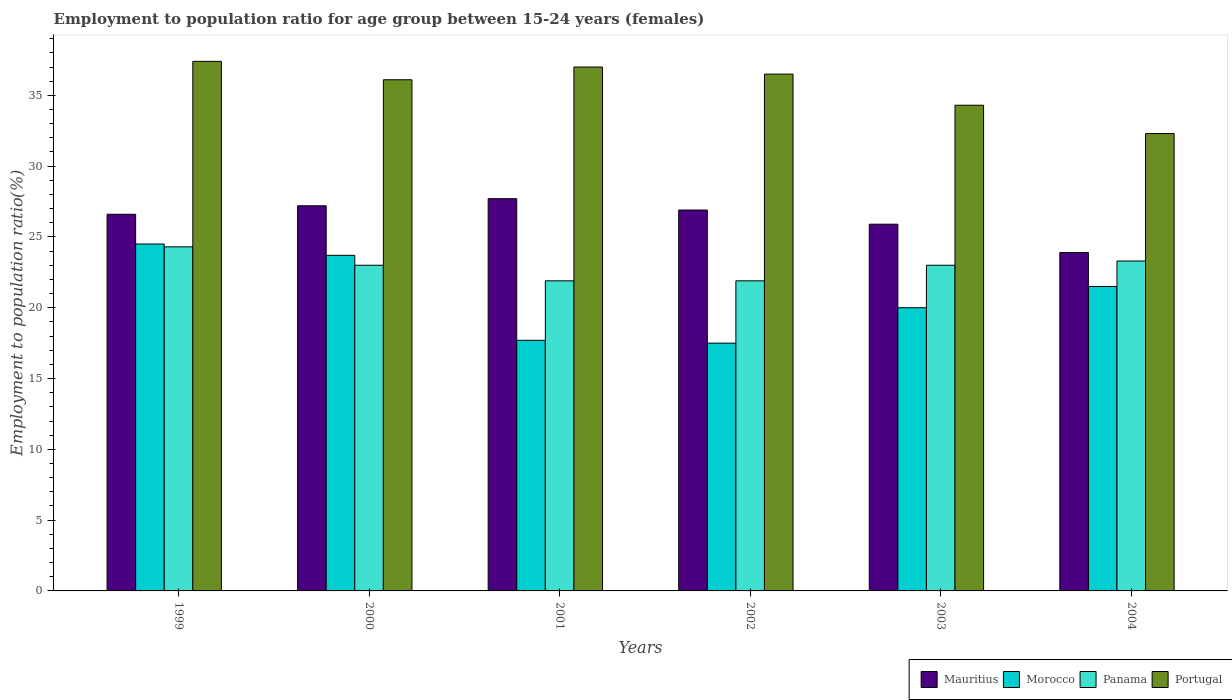How many different coloured bars are there?
Provide a short and direct response. 4. Are the number of bars on each tick of the X-axis equal?
Offer a very short reply. Yes. How many bars are there on the 4th tick from the left?
Your answer should be very brief. 4. What is the employment to population ratio in Portugal in 2002?
Offer a terse response. 36.5. Across all years, what is the maximum employment to population ratio in Portugal?
Give a very brief answer. 37.4. Across all years, what is the minimum employment to population ratio in Panama?
Offer a terse response. 21.9. In which year was the employment to population ratio in Panama maximum?
Offer a very short reply. 1999. What is the total employment to population ratio in Portugal in the graph?
Provide a short and direct response. 213.6. What is the difference between the employment to population ratio in Morocco in 1999 and that in 2002?
Make the answer very short. 7. What is the difference between the employment to population ratio in Morocco in 2003 and the employment to population ratio in Mauritius in 2004?
Ensure brevity in your answer.  -3.9. What is the average employment to population ratio in Morocco per year?
Offer a very short reply. 20.82. In the year 2003, what is the difference between the employment to population ratio in Portugal and employment to population ratio in Morocco?
Offer a terse response. 14.3. What is the ratio of the employment to population ratio in Mauritius in 2003 to that in 2004?
Your answer should be compact. 1.08. Is the employment to population ratio in Morocco in 1999 less than that in 2001?
Offer a very short reply. No. What is the difference between the highest and the second highest employment to population ratio in Morocco?
Provide a succinct answer. 0.8. What is the difference between the highest and the lowest employment to population ratio in Mauritius?
Keep it short and to the point. 3.8. In how many years, is the employment to population ratio in Portugal greater than the average employment to population ratio in Portugal taken over all years?
Provide a succinct answer. 4. What does the 1st bar from the left in 2000 represents?
Provide a succinct answer. Mauritius. Is it the case that in every year, the sum of the employment to population ratio in Mauritius and employment to population ratio in Portugal is greater than the employment to population ratio in Morocco?
Offer a very short reply. Yes. How many years are there in the graph?
Keep it short and to the point. 6. What is the difference between two consecutive major ticks on the Y-axis?
Your answer should be compact. 5. Does the graph contain any zero values?
Offer a very short reply. No. Does the graph contain grids?
Provide a short and direct response. No. Where does the legend appear in the graph?
Offer a terse response. Bottom right. How many legend labels are there?
Ensure brevity in your answer.  4. How are the legend labels stacked?
Provide a short and direct response. Horizontal. What is the title of the graph?
Offer a terse response. Employment to population ratio for age group between 15-24 years (females). Does "Liechtenstein" appear as one of the legend labels in the graph?
Your answer should be compact. No. What is the label or title of the X-axis?
Offer a very short reply. Years. What is the label or title of the Y-axis?
Ensure brevity in your answer.  Employment to population ratio(%). What is the Employment to population ratio(%) of Mauritius in 1999?
Provide a succinct answer. 26.6. What is the Employment to population ratio(%) in Morocco in 1999?
Provide a succinct answer. 24.5. What is the Employment to population ratio(%) of Panama in 1999?
Your answer should be very brief. 24.3. What is the Employment to population ratio(%) of Portugal in 1999?
Offer a very short reply. 37.4. What is the Employment to population ratio(%) of Mauritius in 2000?
Provide a succinct answer. 27.2. What is the Employment to population ratio(%) of Morocco in 2000?
Ensure brevity in your answer.  23.7. What is the Employment to population ratio(%) in Panama in 2000?
Ensure brevity in your answer.  23. What is the Employment to population ratio(%) of Portugal in 2000?
Your answer should be compact. 36.1. What is the Employment to population ratio(%) in Mauritius in 2001?
Offer a very short reply. 27.7. What is the Employment to population ratio(%) in Morocco in 2001?
Your answer should be compact. 17.7. What is the Employment to population ratio(%) of Panama in 2001?
Provide a succinct answer. 21.9. What is the Employment to population ratio(%) of Portugal in 2001?
Your answer should be compact. 37. What is the Employment to population ratio(%) of Mauritius in 2002?
Provide a short and direct response. 26.9. What is the Employment to population ratio(%) of Morocco in 2002?
Give a very brief answer. 17.5. What is the Employment to population ratio(%) in Panama in 2002?
Your response must be concise. 21.9. What is the Employment to population ratio(%) in Portugal in 2002?
Ensure brevity in your answer.  36.5. What is the Employment to population ratio(%) in Mauritius in 2003?
Provide a short and direct response. 25.9. What is the Employment to population ratio(%) in Morocco in 2003?
Offer a very short reply. 20. What is the Employment to population ratio(%) in Panama in 2003?
Give a very brief answer. 23. What is the Employment to population ratio(%) in Portugal in 2003?
Make the answer very short. 34.3. What is the Employment to population ratio(%) of Mauritius in 2004?
Provide a short and direct response. 23.9. What is the Employment to population ratio(%) in Panama in 2004?
Offer a very short reply. 23.3. What is the Employment to population ratio(%) in Portugal in 2004?
Ensure brevity in your answer.  32.3. Across all years, what is the maximum Employment to population ratio(%) of Mauritius?
Ensure brevity in your answer.  27.7. Across all years, what is the maximum Employment to population ratio(%) of Morocco?
Ensure brevity in your answer.  24.5. Across all years, what is the maximum Employment to population ratio(%) in Panama?
Your response must be concise. 24.3. Across all years, what is the maximum Employment to population ratio(%) in Portugal?
Provide a succinct answer. 37.4. Across all years, what is the minimum Employment to population ratio(%) of Mauritius?
Offer a terse response. 23.9. Across all years, what is the minimum Employment to population ratio(%) in Panama?
Give a very brief answer. 21.9. Across all years, what is the minimum Employment to population ratio(%) in Portugal?
Offer a very short reply. 32.3. What is the total Employment to population ratio(%) in Mauritius in the graph?
Provide a succinct answer. 158.2. What is the total Employment to population ratio(%) of Morocco in the graph?
Offer a terse response. 124.9. What is the total Employment to population ratio(%) in Panama in the graph?
Give a very brief answer. 137.4. What is the total Employment to population ratio(%) in Portugal in the graph?
Your response must be concise. 213.6. What is the difference between the Employment to population ratio(%) in Mauritius in 1999 and that in 2000?
Your answer should be very brief. -0.6. What is the difference between the Employment to population ratio(%) in Morocco in 1999 and that in 2000?
Provide a succinct answer. 0.8. What is the difference between the Employment to population ratio(%) of Mauritius in 1999 and that in 2001?
Keep it short and to the point. -1.1. What is the difference between the Employment to population ratio(%) in Morocco in 1999 and that in 2001?
Offer a terse response. 6.8. What is the difference between the Employment to population ratio(%) of Panama in 1999 and that in 2001?
Give a very brief answer. 2.4. What is the difference between the Employment to population ratio(%) of Portugal in 1999 and that in 2001?
Provide a succinct answer. 0.4. What is the difference between the Employment to population ratio(%) in Mauritius in 1999 and that in 2002?
Your answer should be compact. -0.3. What is the difference between the Employment to population ratio(%) of Morocco in 1999 and that in 2002?
Give a very brief answer. 7. What is the difference between the Employment to population ratio(%) in Portugal in 1999 and that in 2002?
Offer a terse response. 0.9. What is the difference between the Employment to population ratio(%) of Mauritius in 1999 and that in 2003?
Your response must be concise. 0.7. What is the difference between the Employment to population ratio(%) in Morocco in 1999 and that in 2003?
Offer a terse response. 4.5. What is the difference between the Employment to population ratio(%) of Panama in 1999 and that in 2003?
Provide a short and direct response. 1.3. What is the difference between the Employment to population ratio(%) in Portugal in 1999 and that in 2003?
Give a very brief answer. 3.1. What is the difference between the Employment to population ratio(%) of Mauritius in 1999 and that in 2004?
Provide a short and direct response. 2.7. What is the difference between the Employment to population ratio(%) in Panama in 1999 and that in 2004?
Give a very brief answer. 1. What is the difference between the Employment to population ratio(%) of Portugal in 1999 and that in 2004?
Your response must be concise. 5.1. What is the difference between the Employment to population ratio(%) of Panama in 2000 and that in 2001?
Give a very brief answer. 1.1. What is the difference between the Employment to population ratio(%) in Portugal in 2000 and that in 2001?
Offer a very short reply. -0.9. What is the difference between the Employment to population ratio(%) in Morocco in 2000 and that in 2002?
Offer a very short reply. 6.2. What is the difference between the Employment to population ratio(%) of Panama in 2000 and that in 2003?
Provide a short and direct response. 0. What is the difference between the Employment to population ratio(%) of Portugal in 2000 and that in 2003?
Keep it short and to the point. 1.8. What is the difference between the Employment to population ratio(%) in Panama in 2000 and that in 2004?
Provide a succinct answer. -0.3. What is the difference between the Employment to population ratio(%) in Portugal in 2001 and that in 2002?
Offer a terse response. 0.5. What is the difference between the Employment to population ratio(%) of Morocco in 2001 and that in 2003?
Your answer should be compact. -2.3. What is the difference between the Employment to population ratio(%) of Panama in 2001 and that in 2003?
Give a very brief answer. -1.1. What is the difference between the Employment to population ratio(%) of Portugal in 2001 and that in 2003?
Your response must be concise. 2.7. What is the difference between the Employment to population ratio(%) in Mauritius in 2001 and that in 2004?
Provide a short and direct response. 3.8. What is the difference between the Employment to population ratio(%) of Panama in 2001 and that in 2004?
Offer a very short reply. -1.4. What is the difference between the Employment to population ratio(%) in Portugal in 2001 and that in 2004?
Your response must be concise. 4.7. What is the difference between the Employment to population ratio(%) of Mauritius in 2002 and that in 2003?
Offer a terse response. 1. What is the difference between the Employment to population ratio(%) of Panama in 2002 and that in 2003?
Offer a very short reply. -1.1. What is the difference between the Employment to population ratio(%) of Portugal in 2002 and that in 2003?
Give a very brief answer. 2.2. What is the difference between the Employment to population ratio(%) of Morocco in 2002 and that in 2004?
Provide a succinct answer. -4. What is the difference between the Employment to population ratio(%) of Morocco in 2003 and that in 2004?
Give a very brief answer. -1.5. What is the difference between the Employment to population ratio(%) in Mauritius in 1999 and the Employment to population ratio(%) in Morocco in 2000?
Your response must be concise. 2.9. What is the difference between the Employment to population ratio(%) in Mauritius in 1999 and the Employment to population ratio(%) in Panama in 2000?
Ensure brevity in your answer.  3.6. What is the difference between the Employment to population ratio(%) of Morocco in 1999 and the Employment to population ratio(%) of Panama in 2000?
Your answer should be very brief. 1.5. What is the difference between the Employment to population ratio(%) in Morocco in 1999 and the Employment to population ratio(%) in Portugal in 2000?
Offer a very short reply. -11.6. What is the difference between the Employment to population ratio(%) of Mauritius in 1999 and the Employment to population ratio(%) of Panama in 2001?
Offer a very short reply. 4.7. What is the difference between the Employment to population ratio(%) in Morocco in 1999 and the Employment to population ratio(%) in Panama in 2001?
Your response must be concise. 2.6. What is the difference between the Employment to population ratio(%) of Mauritius in 1999 and the Employment to population ratio(%) of Morocco in 2002?
Provide a short and direct response. 9.1. What is the difference between the Employment to population ratio(%) of Mauritius in 1999 and the Employment to population ratio(%) of Panama in 2002?
Give a very brief answer. 4.7. What is the difference between the Employment to population ratio(%) of Mauritius in 1999 and the Employment to population ratio(%) of Portugal in 2002?
Your response must be concise. -9.9. What is the difference between the Employment to population ratio(%) in Panama in 1999 and the Employment to population ratio(%) in Portugal in 2002?
Make the answer very short. -12.2. What is the difference between the Employment to population ratio(%) of Mauritius in 1999 and the Employment to population ratio(%) of Portugal in 2003?
Give a very brief answer. -7.7. What is the difference between the Employment to population ratio(%) in Morocco in 1999 and the Employment to population ratio(%) in Panama in 2003?
Offer a very short reply. 1.5. What is the difference between the Employment to population ratio(%) in Morocco in 1999 and the Employment to population ratio(%) in Panama in 2004?
Provide a succinct answer. 1.2. What is the difference between the Employment to population ratio(%) of Panama in 1999 and the Employment to population ratio(%) of Portugal in 2004?
Your response must be concise. -8. What is the difference between the Employment to population ratio(%) of Mauritius in 2000 and the Employment to population ratio(%) of Panama in 2001?
Offer a terse response. 5.3. What is the difference between the Employment to population ratio(%) in Morocco in 2000 and the Employment to population ratio(%) in Panama in 2001?
Make the answer very short. 1.8. What is the difference between the Employment to population ratio(%) of Morocco in 2000 and the Employment to population ratio(%) of Portugal in 2001?
Keep it short and to the point. -13.3. What is the difference between the Employment to population ratio(%) of Panama in 2000 and the Employment to population ratio(%) of Portugal in 2001?
Provide a succinct answer. -14. What is the difference between the Employment to population ratio(%) of Mauritius in 2000 and the Employment to population ratio(%) of Morocco in 2002?
Offer a very short reply. 9.7. What is the difference between the Employment to population ratio(%) in Mauritius in 2000 and the Employment to population ratio(%) in Panama in 2002?
Give a very brief answer. 5.3. What is the difference between the Employment to population ratio(%) of Morocco in 2000 and the Employment to population ratio(%) of Panama in 2002?
Keep it short and to the point. 1.8. What is the difference between the Employment to population ratio(%) in Morocco in 2000 and the Employment to population ratio(%) in Portugal in 2002?
Make the answer very short. -12.8. What is the difference between the Employment to population ratio(%) in Mauritius in 2000 and the Employment to population ratio(%) in Morocco in 2003?
Offer a terse response. 7.2. What is the difference between the Employment to population ratio(%) in Morocco in 2000 and the Employment to population ratio(%) in Panama in 2003?
Give a very brief answer. 0.7. What is the difference between the Employment to population ratio(%) of Panama in 2000 and the Employment to population ratio(%) of Portugal in 2003?
Provide a succinct answer. -11.3. What is the difference between the Employment to population ratio(%) of Mauritius in 2000 and the Employment to population ratio(%) of Panama in 2004?
Provide a succinct answer. 3.9. What is the difference between the Employment to population ratio(%) in Morocco in 2000 and the Employment to population ratio(%) in Panama in 2004?
Provide a short and direct response. 0.4. What is the difference between the Employment to population ratio(%) in Panama in 2000 and the Employment to population ratio(%) in Portugal in 2004?
Give a very brief answer. -9.3. What is the difference between the Employment to population ratio(%) of Mauritius in 2001 and the Employment to population ratio(%) of Morocco in 2002?
Provide a succinct answer. 10.2. What is the difference between the Employment to population ratio(%) in Mauritius in 2001 and the Employment to population ratio(%) in Panama in 2002?
Ensure brevity in your answer.  5.8. What is the difference between the Employment to population ratio(%) of Mauritius in 2001 and the Employment to population ratio(%) of Portugal in 2002?
Your response must be concise. -8.8. What is the difference between the Employment to population ratio(%) in Morocco in 2001 and the Employment to population ratio(%) in Portugal in 2002?
Ensure brevity in your answer.  -18.8. What is the difference between the Employment to population ratio(%) in Panama in 2001 and the Employment to population ratio(%) in Portugal in 2002?
Provide a succinct answer. -14.6. What is the difference between the Employment to population ratio(%) in Mauritius in 2001 and the Employment to population ratio(%) in Portugal in 2003?
Offer a very short reply. -6.6. What is the difference between the Employment to population ratio(%) of Morocco in 2001 and the Employment to population ratio(%) of Portugal in 2003?
Your answer should be very brief. -16.6. What is the difference between the Employment to population ratio(%) in Panama in 2001 and the Employment to population ratio(%) in Portugal in 2003?
Your answer should be compact. -12.4. What is the difference between the Employment to population ratio(%) of Mauritius in 2001 and the Employment to population ratio(%) of Morocco in 2004?
Offer a terse response. 6.2. What is the difference between the Employment to population ratio(%) of Morocco in 2001 and the Employment to population ratio(%) of Panama in 2004?
Provide a succinct answer. -5.6. What is the difference between the Employment to population ratio(%) of Morocco in 2001 and the Employment to population ratio(%) of Portugal in 2004?
Provide a succinct answer. -14.6. What is the difference between the Employment to population ratio(%) of Panama in 2001 and the Employment to population ratio(%) of Portugal in 2004?
Make the answer very short. -10.4. What is the difference between the Employment to population ratio(%) in Mauritius in 2002 and the Employment to population ratio(%) in Morocco in 2003?
Provide a succinct answer. 6.9. What is the difference between the Employment to population ratio(%) of Mauritius in 2002 and the Employment to population ratio(%) of Panama in 2003?
Ensure brevity in your answer.  3.9. What is the difference between the Employment to population ratio(%) in Mauritius in 2002 and the Employment to population ratio(%) in Portugal in 2003?
Provide a succinct answer. -7.4. What is the difference between the Employment to population ratio(%) of Morocco in 2002 and the Employment to population ratio(%) of Portugal in 2003?
Provide a short and direct response. -16.8. What is the difference between the Employment to population ratio(%) of Panama in 2002 and the Employment to population ratio(%) of Portugal in 2003?
Provide a short and direct response. -12.4. What is the difference between the Employment to population ratio(%) of Mauritius in 2002 and the Employment to population ratio(%) of Portugal in 2004?
Keep it short and to the point. -5.4. What is the difference between the Employment to population ratio(%) of Morocco in 2002 and the Employment to population ratio(%) of Portugal in 2004?
Give a very brief answer. -14.8. What is the difference between the Employment to population ratio(%) of Panama in 2002 and the Employment to population ratio(%) of Portugal in 2004?
Your response must be concise. -10.4. What is the difference between the Employment to population ratio(%) in Mauritius in 2003 and the Employment to population ratio(%) in Morocco in 2004?
Your answer should be compact. 4.4. What is the difference between the Employment to population ratio(%) in Mauritius in 2003 and the Employment to population ratio(%) in Portugal in 2004?
Make the answer very short. -6.4. What is the difference between the Employment to population ratio(%) in Morocco in 2003 and the Employment to population ratio(%) in Panama in 2004?
Your answer should be compact. -3.3. What is the difference between the Employment to population ratio(%) in Morocco in 2003 and the Employment to population ratio(%) in Portugal in 2004?
Offer a terse response. -12.3. What is the difference between the Employment to population ratio(%) of Panama in 2003 and the Employment to population ratio(%) of Portugal in 2004?
Offer a terse response. -9.3. What is the average Employment to population ratio(%) of Mauritius per year?
Provide a short and direct response. 26.37. What is the average Employment to population ratio(%) in Morocco per year?
Provide a short and direct response. 20.82. What is the average Employment to population ratio(%) in Panama per year?
Give a very brief answer. 22.9. What is the average Employment to population ratio(%) in Portugal per year?
Ensure brevity in your answer.  35.6. In the year 1999, what is the difference between the Employment to population ratio(%) in Mauritius and Employment to population ratio(%) in Morocco?
Offer a terse response. 2.1. In the year 1999, what is the difference between the Employment to population ratio(%) in Mauritius and Employment to population ratio(%) in Panama?
Make the answer very short. 2.3. In the year 1999, what is the difference between the Employment to population ratio(%) in Mauritius and Employment to population ratio(%) in Portugal?
Your response must be concise. -10.8. In the year 1999, what is the difference between the Employment to population ratio(%) of Morocco and Employment to population ratio(%) of Panama?
Keep it short and to the point. 0.2. In the year 1999, what is the difference between the Employment to population ratio(%) in Panama and Employment to population ratio(%) in Portugal?
Your answer should be very brief. -13.1. In the year 2000, what is the difference between the Employment to population ratio(%) in Mauritius and Employment to population ratio(%) in Morocco?
Provide a short and direct response. 3.5. In the year 2000, what is the difference between the Employment to population ratio(%) of Mauritius and Employment to population ratio(%) of Portugal?
Give a very brief answer. -8.9. In the year 2000, what is the difference between the Employment to population ratio(%) of Morocco and Employment to population ratio(%) of Panama?
Make the answer very short. 0.7. In the year 2001, what is the difference between the Employment to population ratio(%) of Morocco and Employment to population ratio(%) of Panama?
Your answer should be compact. -4.2. In the year 2001, what is the difference between the Employment to population ratio(%) in Morocco and Employment to population ratio(%) in Portugal?
Offer a very short reply. -19.3. In the year 2001, what is the difference between the Employment to population ratio(%) of Panama and Employment to population ratio(%) of Portugal?
Make the answer very short. -15.1. In the year 2002, what is the difference between the Employment to population ratio(%) in Mauritius and Employment to population ratio(%) in Panama?
Make the answer very short. 5. In the year 2002, what is the difference between the Employment to population ratio(%) in Morocco and Employment to population ratio(%) in Panama?
Your answer should be compact. -4.4. In the year 2002, what is the difference between the Employment to population ratio(%) of Morocco and Employment to population ratio(%) of Portugal?
Provide a succinct answer. -19. In the year 2002, what is the difference between the Employment to population ratio(%) of Panama and Employment to population ratio(%) of Portugal?
Ensure brevity in your answer.  -14.6. In the year 2003, what is the difference between the Employment to population ratio(%) in Mauritius and Employment to population ratio(%) in Panama?
Provide a succinct answer. 2.9. In the year 2003, what is the difference between the Employment to population ratio(%) in Morocco and Employment to population ratio(%) in Panama?
Ensure brevity in your answer.  -3. In the year 2003, what is the difference between the Employment to population ratio(%) of Morocco and Employment to population ratio(%) of Portugal?
Offer a terse response. -14.3. In the year 2003, what is the difference between the Employment to population ratio(%) in Panama and Employment to population ratio(%) in Portugal?
Give a very brief answer. -11.3. In the year 2004, what is the difference between the Employment to population ratio(%) in Panama and Employment to population ratio(%) in Portugal?
Provide a short and direct response. -9. What is the ratio of the Employment to population ratio(%) of Mauritius in 1999 to that in 2000?
Provide a succinct answer. 0.98. What is the ratio of the Employment to population ratio(%) of Morocco in 1999 to that in 2000?
Make the answer very short. 1.03. What is the ratio of the Employment to population ratio(%) of Panama in 1999 to that in 2000?
Make the answer very short. 1.06. What is the ratio of the Employment to population ratio(%) in Portugal in 1999 to that in 2000?
Ensure brevity in your answer.  1.04. What is the ratio of the Employment to population ratio(%) of Mauritius in 1999 to that in 2001?
Provide a succinct answer. 0.96. What is the ratio of the Employment to population ratio(%) of Morocco in 1999 to that in 2001?
Offer a very short reply. 1.38. What is the ratio of the Employment to population ratio(%) in Panama in 1999 to that in 2001?
Offer a very short reply. 1.11. What is the ratio of the Employment to population ratio(%) in Portugal in 1999 to that in 2001?
Your answer should be compact. 1.01. What is the ratio of the Employment to population ratio(%) of Mauritius in 1999 to that in 2002?
Offer a very short reply. 0.99. What is the ratio of the Employment to population ratio(%) in Morocco in 1999 to that in 2002?
Keep it short and to the point. 1.4. What is the ratio of the Employment to population ratio(%) in Panama in 1999 to that in 2002?
Your answer should be compact. 1.11. What is the ratio of the Employment to population ratio(%) of Portugal in 1999 to that in 2002?
Ensure brevity in your answer.  1.02. What is the ratio of the Employment to population ratio(%) in Morocco in 1999 to that in 2003?
Ensure brevity in your answer.  1.23. What is the ratio of the Employment to population ratio(%) in Panama in 1999 to that in 2003?
Make the answer very short. 1.06. What is the ratio of the Employment to population ratio(%) in Portugal in 1999 to that in 2003?
Offer a terse response. 1.09. What is the ratio of the Employment to population ratio(%) of Mauritius in 1999 to that in 2004?
Your answer should be compact. 1.11. What is the ratio of the Employment to population ratio(%) in Morocco in 1999 to that in 2004?
Provide a succinct answer. 1.14. What is the ratio of the Employment to population ratio(%) of Panama in 1999 to that in 2004?
Offer a very short reply. 1.04. What is the ratio of the Employment to population ratio(%) in Portugal in 1999 to that in 2004?
Your answer should be compact. 1.16. What is the ratio of the Employment to population ratio(%) in Mauritius in 2000 to that in 2001?
Provide a succinct answer. 0.98. What is the ratio of the Employment to population ratio(%) of Morocco in 2000 to that in 2001?
Your answer should be very brief. 1.34. What is the ratio of the Employment to population ratio(%) of Panama in 2000 to that in 2001?
Offer a very short reply. 1.05. What is the ratio of the Employment to population ratio(%) in Portugal in 2000 to that in 2001?
Keep it short and to the point. 0.98. What is the ratio of the Employment to population ratio(%) of Mauritius in 2000 to that in 2002?
Provide a succinct answer. 1.01. What is the ratio of the Employment to population ratio(%) of Morocco in 2000 to that in 2002?
Offer a very short reply. 1.35. What is the ratio of the Employment to population ratio(%) of Panama in 2000 to that in 2002?
Keep it short and to the point. 1.05. What is the ratio of the Employment to population ratio(%) in Portugal in 2000 to that in 2002?
Offer a very short reply. 0.99. What is the ratio of the Employment to population ratio(%) in Mauritius in 2000 to that in 2003?
Your answer should be very brief. 1.05. What is the ratio of the Employment to population ratio(%) of Morocco in 2000 to that in 2003?
Give a very brief answer. 1.19. What is the ratio of the Employment to population ratio(%) in Panama in 2000 to that in 2003?
Make the answer very short. 1. What is the ratio of the Employment to population ratio(%) of Portugal in 2000 to that in 2003?
Your response must be concise. 1.05. What is the ratio of the Employment to population ratio(%) in Mauritius in 2000 to that in 2004?
Your answer should be compact. 1.14. What is the ratio of the Employment to population ratio(%) of Morocco in 2000 to that in 2004?
Your response must be concise. 1.1. What is the ratio of the Employment to population ratio(%) in Panama in 2000 to that in 2004?
Offer a very short reply. 0.99. What is the ratio of the Employment to population ratio(%) of Portugal in 2000 to that in 2004?
Your answer should be compact. 1.12. What is the ratio of the Employment to population ratio(%) of Mauritius in 2001 to that in 2002?
Provide a short and direct response. 1.03. What is the ratio of the Employment to population ratio(%) in Morocco in 2001 to that in 2002?
Your response must be concise. 1.01. What is the ratio of the Employment to population ratio(%) of Panama in 2001 to that in 2002?
Provide a short and direct response. 1. What is the ratio of the Employment to population ratio(%) of Portugal in 2001 to that in 2002?
Make the answer very short. 1.01. What is the ratio of the Employment to population ratio(%) of Mauritius in 2001 to that in 2003?
Give a very brief answer. 1.07. What is the ratio of the Employment to population ratio(%) in Morocco in 2001 to that in 2003?
Offer a very short reply. 0.89. What is the ratio of the Employment to population ratio(%) of Panama in 2001 to that in 2003?
Offer a very short reply. 0.95. What is the ratio of the Employment to population ratio(%) of Portugal in 2001 to that in 2003?
Offer a terse response. 1.08. What is the ratio of the Employment to population ratio(%) in Mauritius in 2001 to that in 2004?
Offer a very short reply. 1.16. What is the ratio of the Employment to population ratio(%) of Morocco in 2001 to that in 2004?
Provide a succinct answer. 0.82. What is the ratio of the Employment to population ratio(%) in Panama in 2001 to that in 2004?
Your response must be concise. 0.94. What is the ratio of the Employment to population ratio(%) in Portugal in 2001 to that in 2004?
Offer a very short reply. 1.15. What is the ratio of the Employment to population ratio(%) in Mauritius in 2002 to that in 2003?
Ensure brevity in your answer.  1.04. What is the ratio of the Employment to population ratio(%) in Panama in 2002 to that in 2003?
Your response must be concise. 0.95. What is the ratio of the Employment to population ratio(%) of Portugal in 2002 to that in 2003?
Your answer should be very brief. 1.06. What is the ratio of the Employment to population ratio(%) of Mauritius in 2002 to that in 2004?
Offer a very short reply. 1.13. What is the ratio of the Employment to population ratio(%) of Morocco in 2002 to that in 2004?
Your answer should be compact. 0.81. What is the ratio of the Employment to population ratio(%) of Panama in 2002 to that in 2004?
Provide a short and direct response. 0.94. What is the ratio of the Employment to population ratio(%) in Portugal in 2002 to that in 2004?
Offer a terse response. 1.13. What is the ratio of the Employment to population ratio(%) of Mauritius in 2003 to that in 2004?
Your answer should be very brief. 1.08. What is the ratio of the Employment to population ratio(%) of Morocco in 2003 to that in 2004?
Make the answer very short. 0.93. What is the ratio of the Employment to population ratio(%) in Panama in 2003 to that in 2004?
Offer a very short reply. 0.99. What is the ratio of the Employment to population ratio(%) in Portugal in 2003 to that in 2004?
Provide a succinct answer. 1.06. What is the difference between the highest and the second highest Employment to population ratio(%) in Portugal?
Your answer should be very brief. 0.4. What is the difference between the highest and the lowest Employment to population ratio(%) of Mauritius?
Offer a terse response. 3.8. What is the difference between the highest and the lowest Employment to population ratio(%) in Morocco?
Keep it short and to the point. 7. What is the difference between the highest and the lowest Employment to population ratio(%) of Panama?
Offer a very short reply. 2.4. What is the difference between the highest and the lowest Employment to population ratio(%) in Portugal?
Offer a terse response. 5.1. 